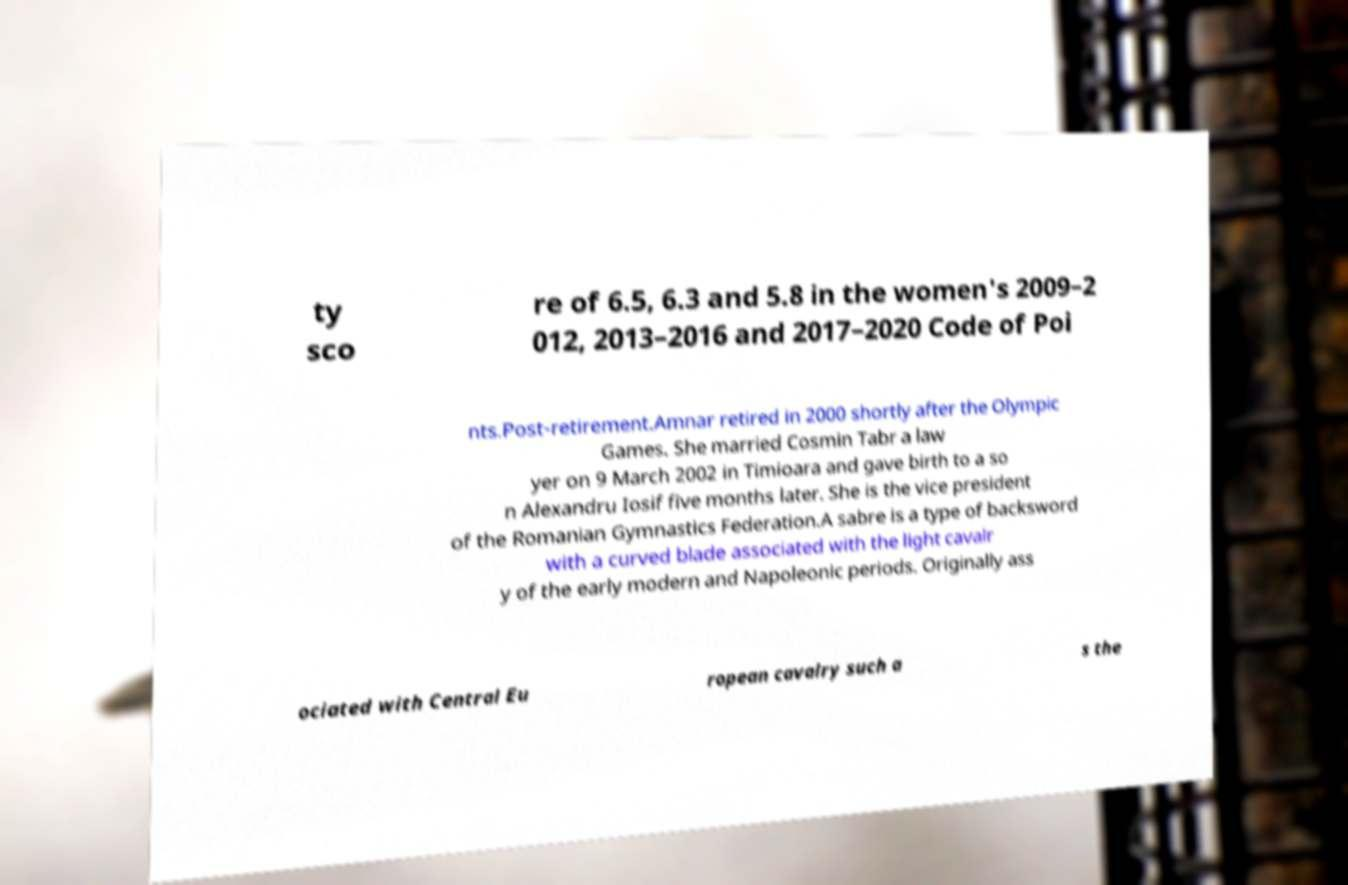Please identify and transcribe the text found in this image. ty sco re of 6.5, 6.3 and 5.8 in the women's 2009–2 012, 2013–2016 and 2017–2020 Code of Poi nts.Post-retirement.Amnar retired in 2000 shortly after the Olympic Games. She married Cosmin Tabr a law yer on 9 March 2002 in Timioara and gave birth to a so n Alexandru Iosif five months later. She is the vice president of the Romanian Gymnastics Federation.A sabre is a type of backsword with a curved blade associated with the light cavalr y of the early modern and Napoleonic periods. Originally ass ociated with Central Eu ropean cavalry such a s the 